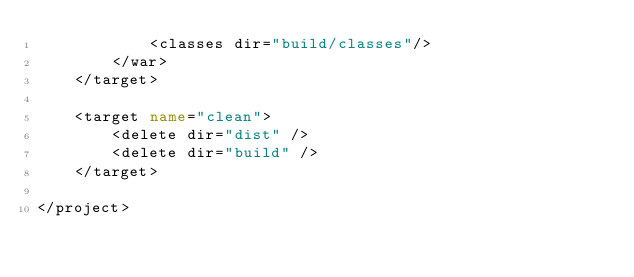Convert code to text. <code><loc_0><loc_0><loc_500><loc_500><_XML_>			<classes dir="build/classes"/>
		</war>
	</target>
	
	<target name="clean">
		<delete dir="dist" />
		<delete dir="build" />
	</target>
	
</project>
</code> 